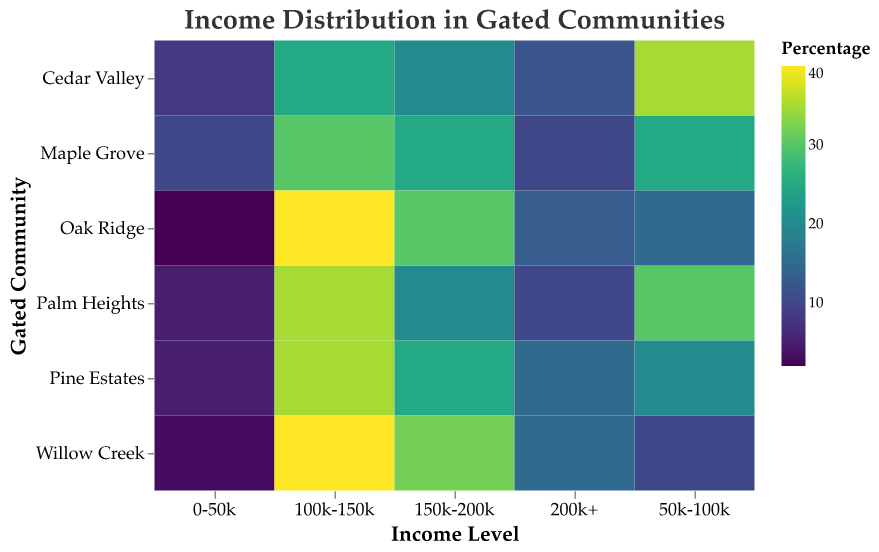What's the title of the heatmap? The title is displayed at the top of the heatmap.
Answer: Income Distribution in Gated Communities Which income level has the highest percentage in Palm Heights? Find the highest value in Palm Heights row and check the corresponding income level. The values in Palm Heights are: 0-50k (5), 50k-100k (30), 100k-150k (35), 150k-200k (20), 200k+ (10).
Answer: 100k-150k Which community has the lowest percentage of residents earning 0-50k? Compare the values in the 0-50k column. Palm Heights (5), Maple Grove (10), Oak Ridge (2), Cedar Valley (8), Pine Estates (5), Willow Creek (3).
Answer: Oak Ridge In which community is the percentage of residents earning 150k-200k the same as those earning 200k+? Check where the values for 150k-200k and 200k+ are equal. The only matching values are in Pine Estates: 150k-200k (25), 200k+ (15).
Answer: Palm Heights If you sum the percentage of residents earning 150k-200k in all communities, what is the total? Add up the values in the 150k-200k row for each community. Palm Heights (20) + Maple Grove (25) + Oak Ridge (30) + Cedar Valley (20) + Pine Estates (25) + Willow Creek (32).
Answer: 152 Which community has the most residents earning between 50k-100k? Compare the values for each community in the 50k-100k category. Palm Heights (30), Maple Grove (25), Oak Ridge (15), Cedar Valley (35), Pine Estates (20), Willow Creek (10).
Answer: Cedar Valley Is there any income level where all communities have less than 10% residents? Check each column if all communities have values less than 10%. No such column meets this criterion; the minimum is 10% in the 200k+ column.
Answer: No In Cedar Valley, which income levels have a higher percentage than the 100k-150k category? Compare the values of income levels to 100k-150k in Cedar Valley. 0-50k (8), 50k-100k (35), 100k-150k (25), 150k-200k (20), 200k+ (12). Only 50k-100k has a higher percentage.
Answer: 50k-100k Which community has the highest percentage of residents earning 100k-150k? Compare the values for each community in the 100k-150k category. Palm Heights (35), Maple Grove (30), Oak Ridge (40), Cedar Valley (25), Pine Estates (35), Willow Creek (40).
Answer: Oak Ridge and Willow Creek 